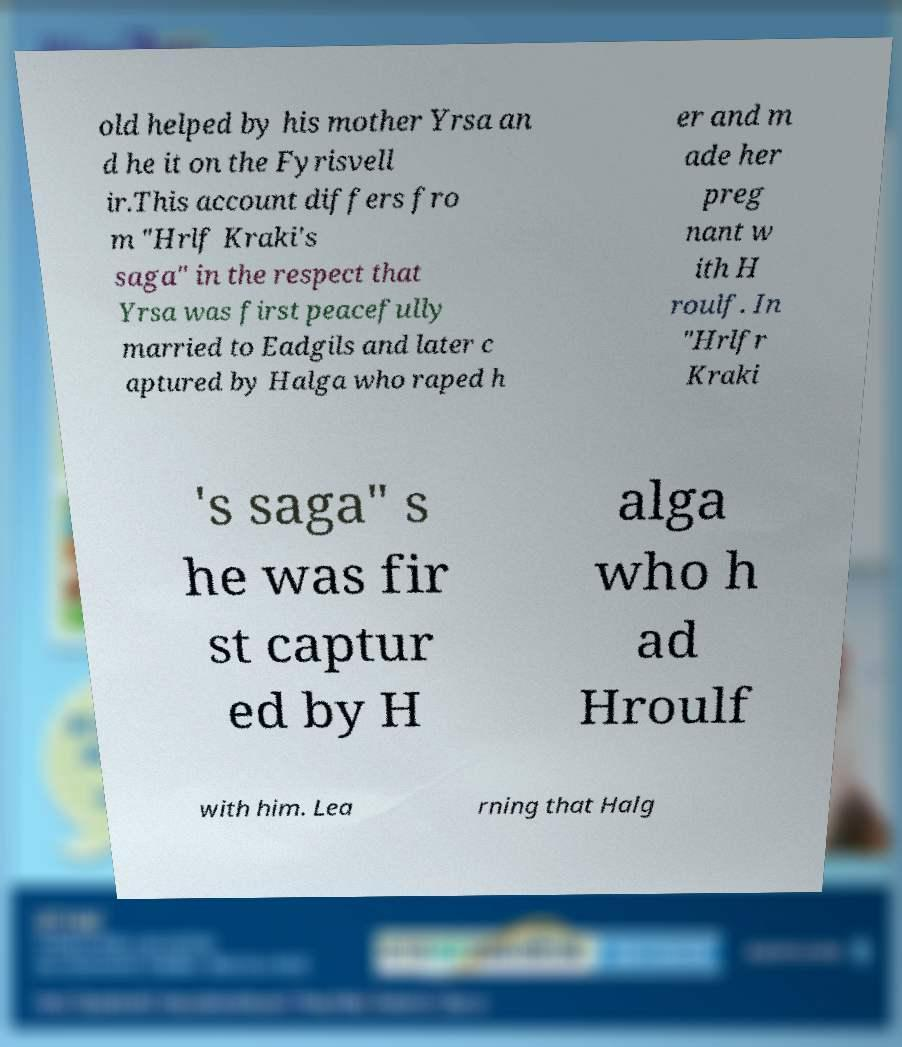Could you assist in decoding the text presented in this image and type it out clearly? old helped by his mother Yrsa an d he it on the Fyrisvell ir.This account differs fro m "Hrlf Kraki's saga" in the respect that Yrsa was first peacefully married to Eadgils and later c aptured by Halga who raped h er and m ade her preg nant w ith H roulf. In "Hrlfr Kraki 's saga" s he was fir st captur ed by H alga who h ad Hroulf with him. Lea rning that Halg 